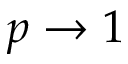<formula> <loc_0><loc_0><loc_500><loc_500>p \rightarrow 1</formula> 